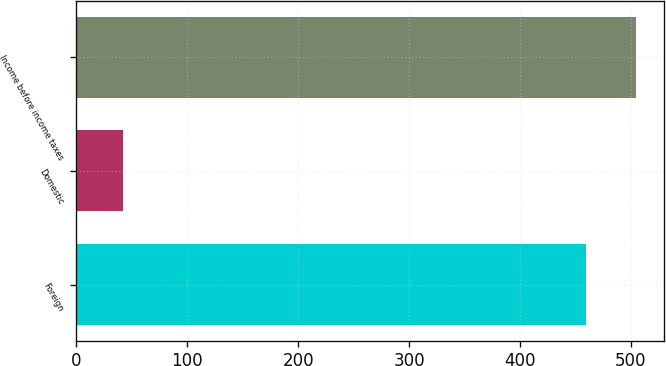<chart> <loc_0><loc_0><loc_500><loc_500><bar_chart><fcel>Foreign<fcel>Domestic<fcel>Income before income taxes<nl><fcel>459<fcel>42<fcel>504.9<nl></chart> 